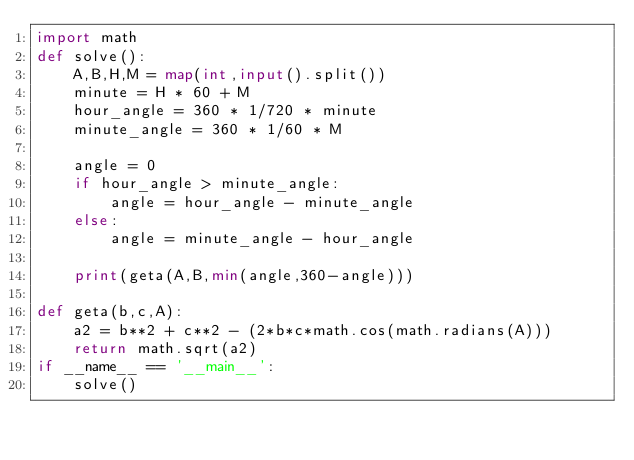Convert code to text. <code><loc_0><loc_0><loc_500><loc_500><_Python_>import math
def solve():
    A,B,H,M = map(int,input().split())
    minute = H * 60 + M
    hour_angle = 360 * 1/720 * minute
    minute_angle = 360 * 1/60 * M

    angle = 0
    if hour_angle > minute_angle:
        angle = hour_angle - minute_angle
    else:
        angle = minute_angle - hour_angle
    
    print(geta(A,B,min(angle,360-angle)))

def geta(b,c,A):
    a2 = b**2 + c**2 - (2*b*c*math.cos(math.radians(A)))
    return math.sqrt(a2)
if __name__ == '__main__':
    solve()</code> 